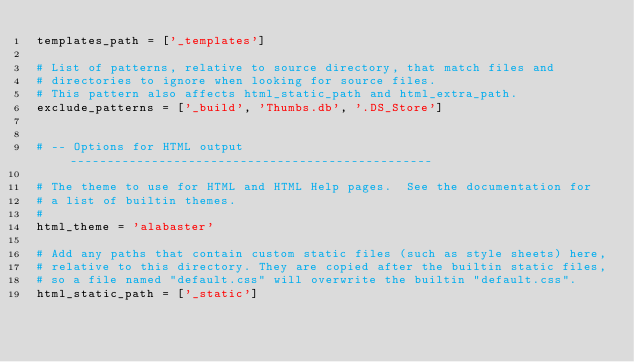Convert code to text. <code><loc_0><loc_0><loc_500><loc_500><_Python_>templates_path = ['_templates']

# List of patterns, relative to source directory, that match files and
# directories to ignore when looking for source files.
# This pattern also affects html_static_path and html_extra_path.
exclude_patterns = ['_build', 'Thumbs.db', '.DS_Store']


# -- Options for HTML output -------------------------------------------------

# The theme to use for HTML and HTML Help pages.  See the documentation for
# a list of builtin themes.
#
html_theme = 'alabaster'

# Add any paths that contain custom static files (such as style sheets) here,
# relative to this directory. They are copied after the builtin static files,
# so a file named "default.css" will overwrite the builtin "default.css".
html_static_path = ['_static']
</code> 